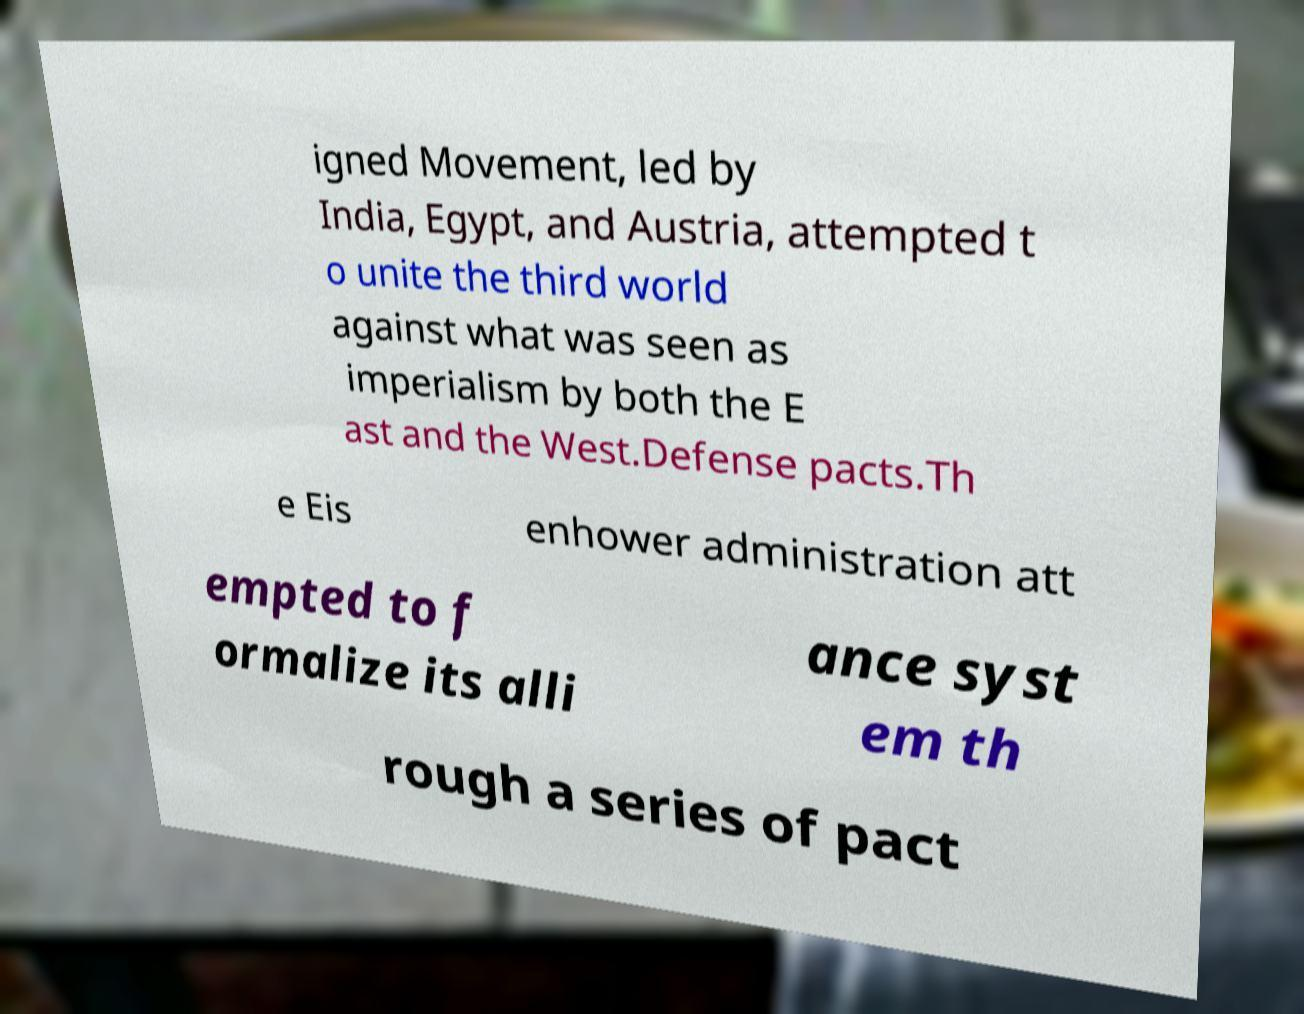For documentation purposes, I need the text within this image transcribed. Could you provide that? igned Movement, led by India, Egypt, and Austria, attempted t o unite the third world against what was seen as imperialism by both the E ast and the West.Defense pacts.Th e Eis enhower administration att empted to f ormalize its alli ance syst em th rough a series of pact 